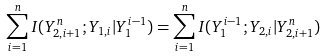Convert formula to latex. <formula><loc_0><loc_0><loc_500><loc_500>\sum _ { i = 1 } ^ { n } I ( Y _ { 2 , i + 1 } ^ { n } ; Y _ { 1 , i } | Y _ { 1 } ^ { i - 1 } ) = \sum _ { i = 1 } ^ { n } I ( Y _ { 1 } ^ { i - 1 } ; Y _ { 2 , i } | Y _ { 2 , i + 1 } ^ { n } )</formula> 